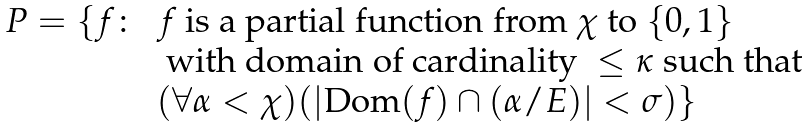Convert formula to latex. <formula><loc_0><loc_0><loc_500><loc_500>\begin{array} { c l c r } P = \{ f \colon & f \text { is a partial function from } \chi \text { to } \{ 0 , 1 \} \\ & \text { with domain of cardinality } \leq \kappa \text { such that} \\ & ( \forall \alpha < \chi ) ( | \text {Dom} ( f ) \cap ( \alpha / E ) | < \sigma ) \} \end{array}</formula> 